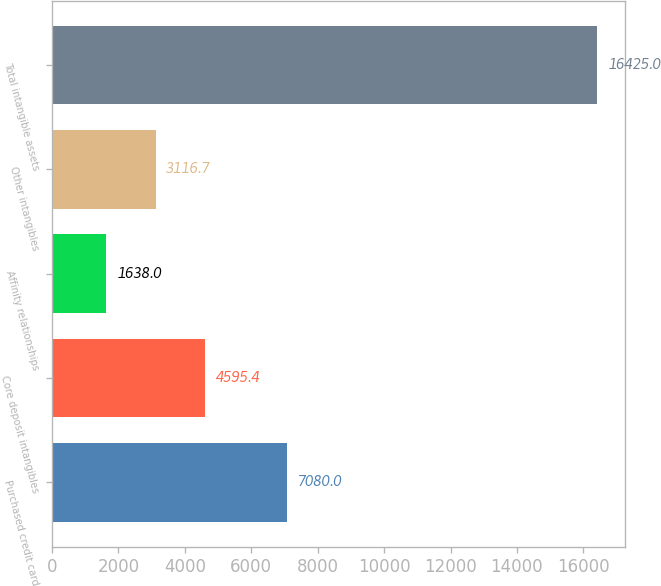Convert chart to OTSL. <chart><loc_0><loc_0><loc_500><loc_500><bar_chart><fcel>Purchased credit card<fcel>Core deposit intangibles<fcel>Affinity relationships<fcel>Other intangibles<fcel>Total intangible assets<nl><fcel>7080<fcel>4595.4<fcel>1638<fcel>3116.7<fcel>16425<nl></chart> 